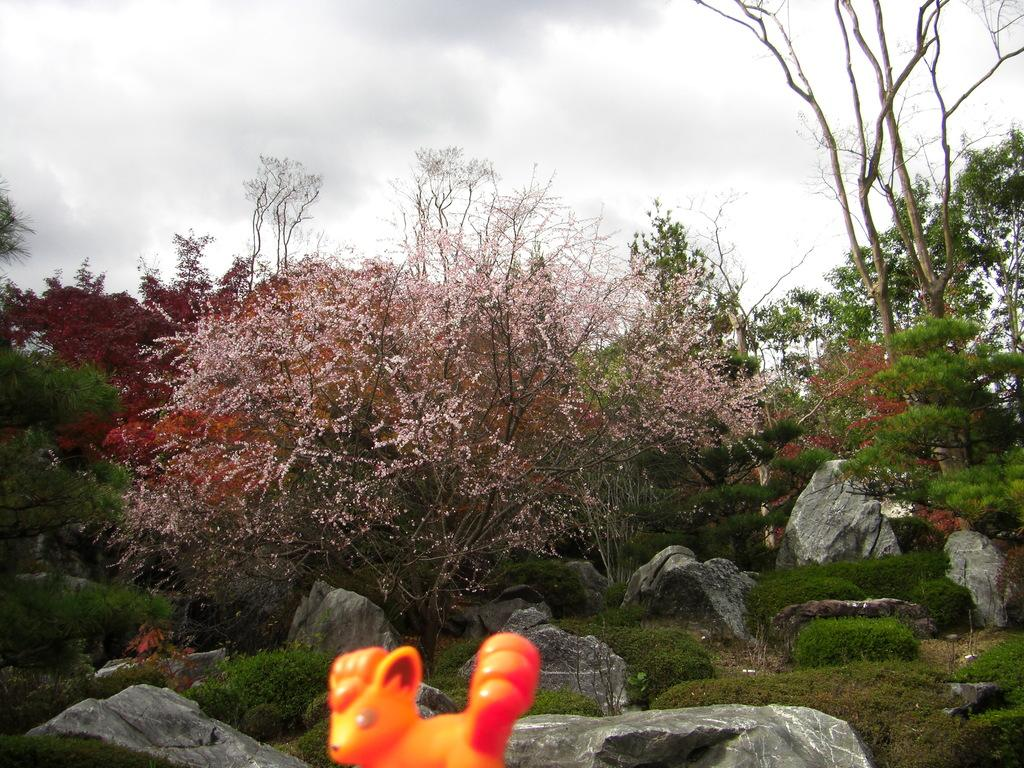What type of natural elements can be seen in the image? There are trees in the image. What other objects can be seen in the image? There are stones in the image. What is visible in the background of the image? The sky is visible in the image. What color is the prominent object in the image? There is an orange-colored object in the image. Can you tell me how many sisters are swimming in the image? There are no sisters or swimming activities depicted in the image. 